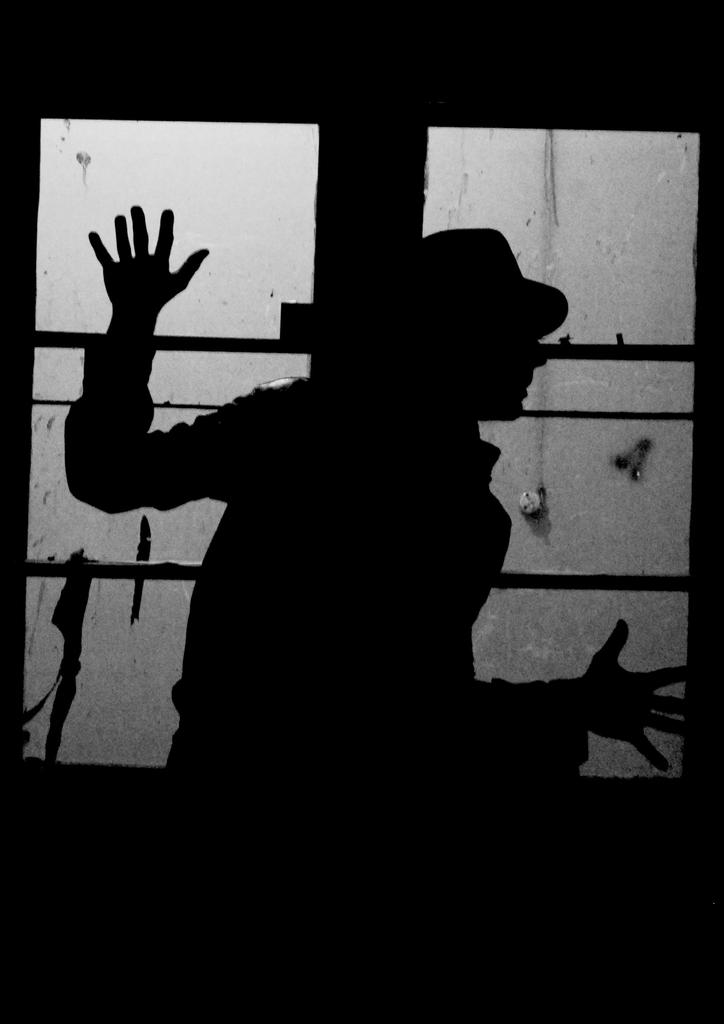What is the main subject of the image? There is a person in the image. Can you describe any objects present in the image? There is a glass in the image. What type of lizards can be seen in the image? There are no lizards present in the image. What religion does the person in the image practice? There is no information about the person's religion in the image. What degree does the person in the image hold? There is no information about the person's education or degrees in the image. 